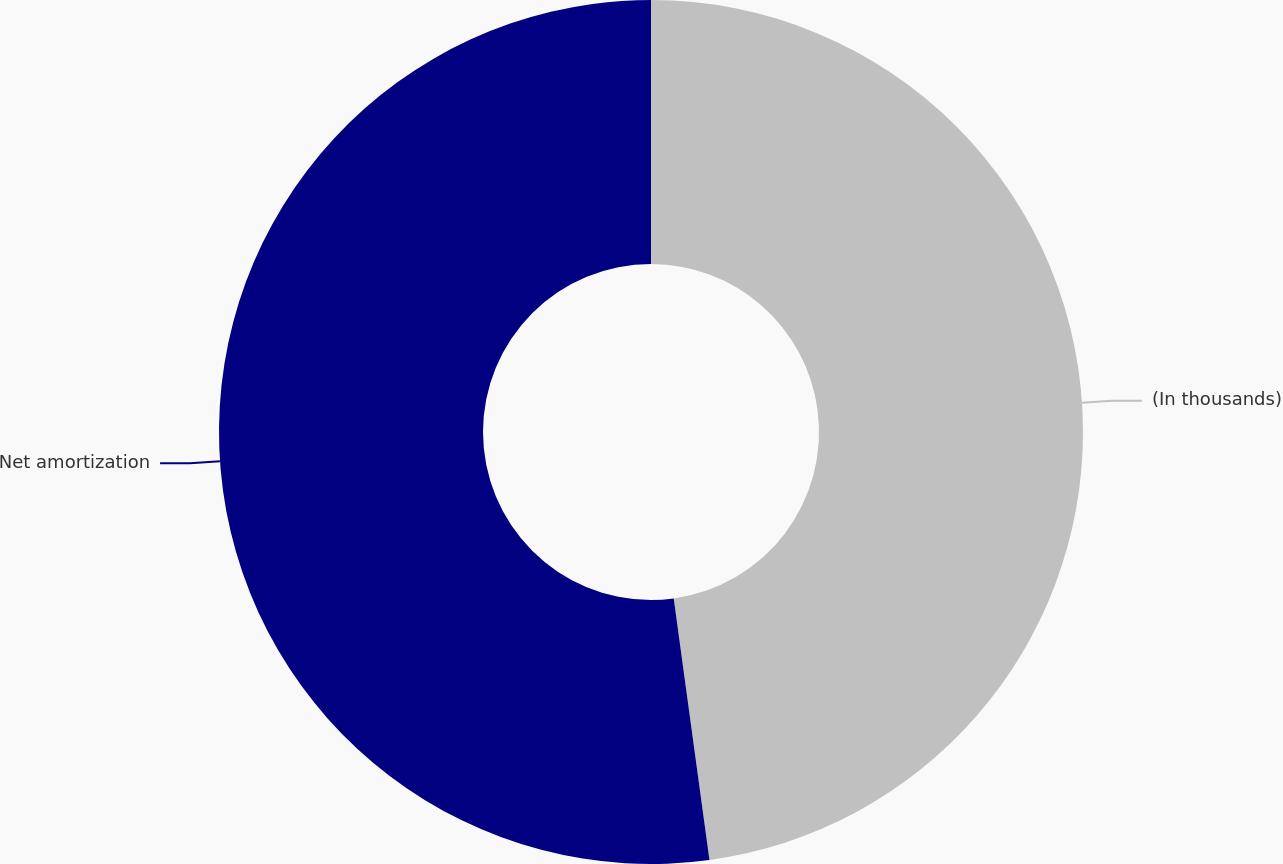Convert chart. <chart><loc_0><loc_0><loc_500><loc_500><pie_chart><fcel>(In thousands)<fcel>Net amortization<nl><fcel>47.84%<fcel>52.16%<nl></chart> 